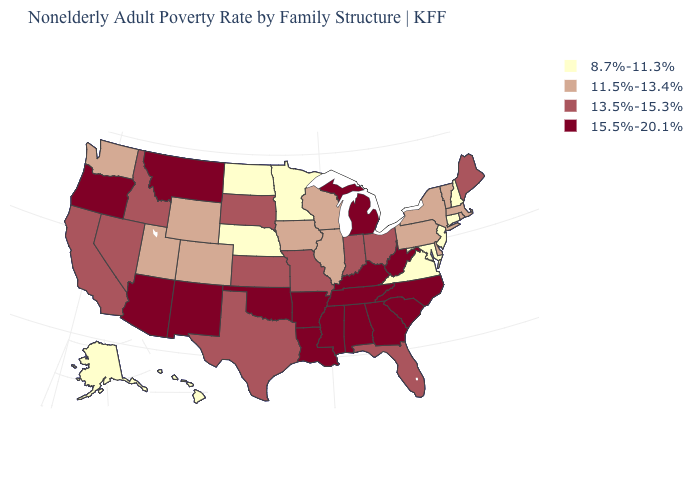Which states have the lowest value in the USA?
Give a very brief answer. Alaska, Connecticut, Hawaii, Maryland, Minnesota, Nebraska, New Hampshire, New Jersey, North Dakota, Virginia. Which states have the lowest value in the MidWest?
Answer briefly. Minnesota, Nebraska, North Dakota. Which states have the lowest value in the West?
Be succinct. Alaska, Hawaii. Name the states that have a value in the range 11.5%-13.4%?
Give a very brief answer. Colorado, Delaware, Illinois, Iowa, Massachusetts, New York, Pennsylvania, Rhode Island, Utah, Vermont, Washington, Wisconsin, Wyoming. Name the states that have a value in the range 13.5%-15.3%?
Keep it brief. California, Florida, Idaho, Indiana, Kansas, Maine, Missouri, Nevada, Ohio, South Dakota, Texas. Which states hav the highest value in the West?
Concise answer only. Arizona, Montana, New Mexico, Oregon. Does the first symbol in the legend represent the smallest category?
Keep it brief. Yes. What is the highest value in the South ?
Answer briefly. 15.5%-20.1%. What is the value of Texas?
Be succinct. 13.5%-15.3%. What is the highest value in the West ?
Answer briefly. 15.5%-20.1%. Does Georgia have the lowest value in the USA?
Quick response, please. No. Name the states that have a value in the range 8.7%-11.3%?
Concise answer only. Alaska, Connecticut, Hawaii, Maryland, Minnesota, Nebraska, New Hampshire, New Jersey, North Dakota, Virginia. Does Connecticut have the highest value in the Northeast?
Quick response, please. No. Is the legend a continuous bar?
Answer briefly. No. What is the value of Minnesota?
Concise answer only. 8.7%-11.3%. 